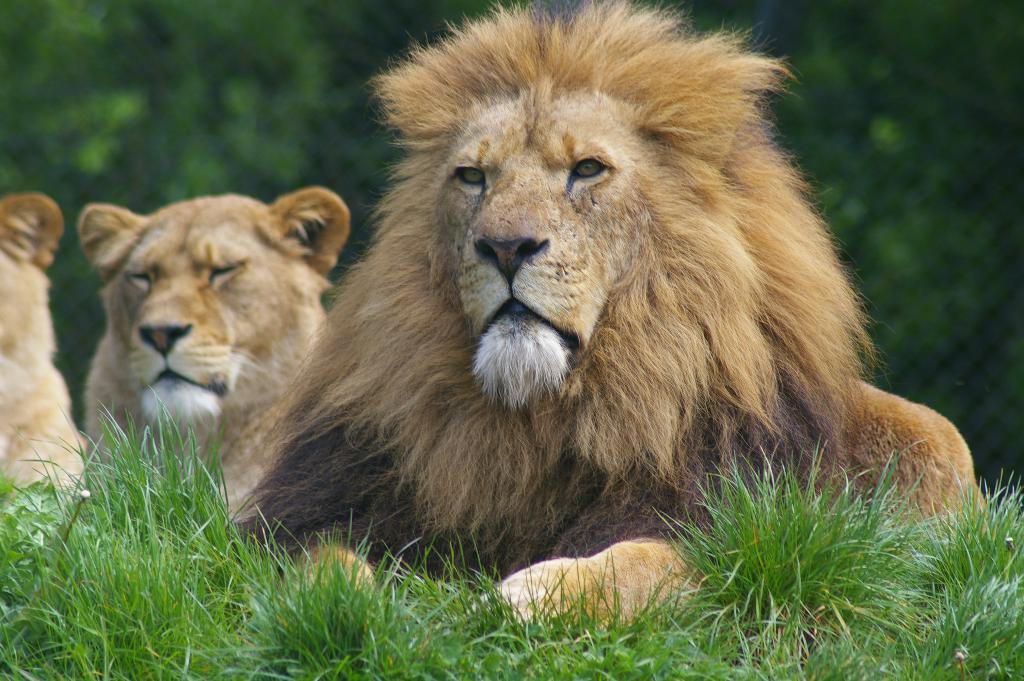Could you give a brief overview of what you see in this image? In this picture there is a lion in the center of the image on the grassland and there are other lions and greenery in the background area of the image. 